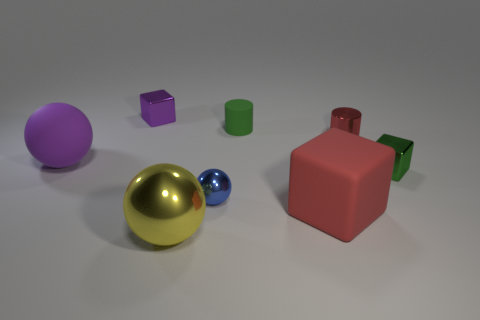Subtract all purple metallic blocks. How many blocks are left? 2 Add 1 big brown shiny cubes. How many objects exist? 9 Subtract all blue balls. How many balls are left? 2 Subtract all balls. How many objects are left? 5 Subtract 1 cylinders. How many cylinders are left? 1 Subtract all purple cylinders. Subtract all yellow balls. How many cylinders are left? 2 Subtract all gray cylinders. How many gray balls are left? 0 Subtract all yellow metal things. Subtract all large yellow metallic things. How many objects are left? 6 Add 7 big cubes. How many big cubes are left? 8 Add 2 big red objects. How many big red objects exist? 3 